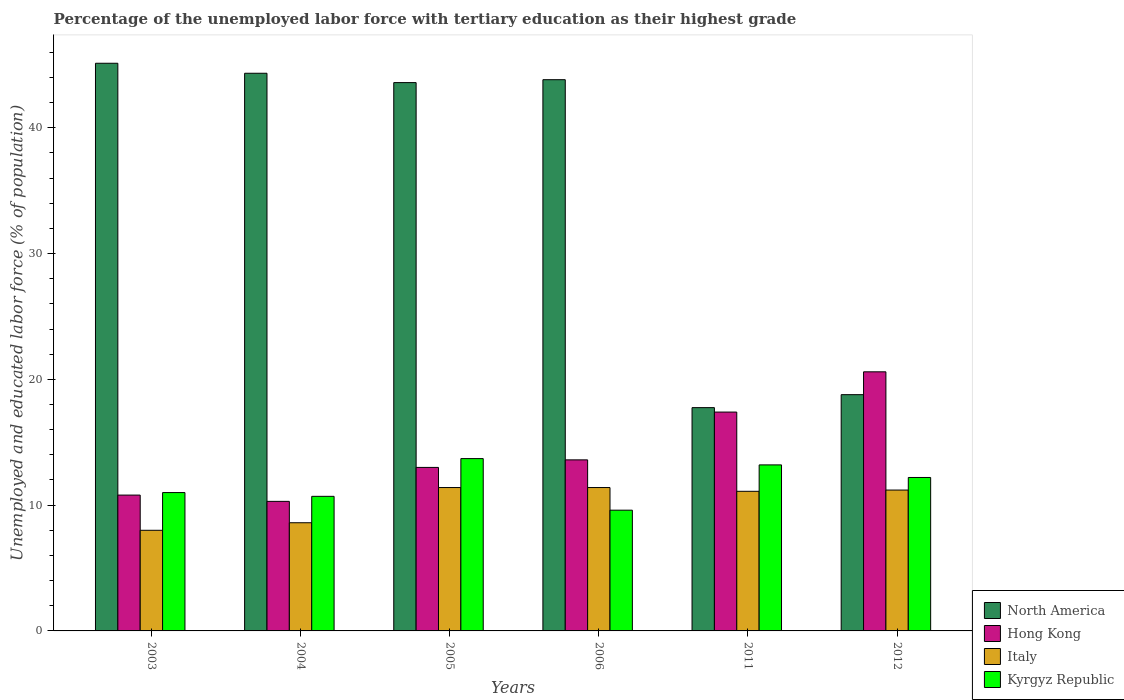How many different coloured bars are there?
Make the answer very short. 4. How many groups of bars are there?
Your answer should be compact. 6. Are the number of bars per tick equal to the number of legend labels?
Provide a short and direct response. Yes. Are the number of bars on each tick of the X-axis equal?
Provide a succinct answer. Yes. How many bars are there on the 5th tick from the right?
Give a very brief answer. 4. What is the percentage of the unemployed labor force with tertiary education in Italy in 2005?
Your answer should be compact. 11.4. Across all years, what is the maximum percentage of the unemployed labor force with tertiary education in North America?
Make the answer very short. 45.13. Across all years, what is the minimum percentage of the unemployed labor force with tertiary education in North America?
Keep it short and to the point. 17.75. What is the total percentage of the unemployed labor force with tertiary education in Kyrgyz Republic in the graph?
Your answer should be very brief. 70.4. What is the difference between the percentage of the unemployed labor force with tertiary education in Kyrgyz Republic in 2005 and that in 2011?
Provide a succinct answer. 0.5. What is the difference between the percentage of the unemployed labor force with tertiary education in North America in 2005 and the percentage of the unemployed labor force with tertiary education in Hong Kong in 2006?
Your response must be concise. 29.99. What is the average percentage of the unemployed labor force with tertiary education in North America per year?
Give a very brief answer. 35.57. In the year 2011, what is the difference between the percentage of the unemployed labor force with tertiary education in North America and percentage of the unemployed labor force with tertiary education in Kyrgyz Republic?
Offer a very short reply. 4.55. In how many years, is the percentage of the unemployed labor force with tertiary education in Italy greater than 36 %?
Offer a terse response. 0. What is the ratio of the percentage of the unemployed labor force with tertiary education in Italy in 2004 to that in 2012?
Offer a terse response. 0.77. What is the difference between the highest and the second highest percentage of the unemployed labor force with tertiary education in Hong Kong?
Provide a short and direct response. 3.2. What is the difference between the highest and the lowest percentage of the unemployed labor force with tertiary education in Kyrgyz Republic?
Ensure brevity in your answer.  4.1. What does the 4th bar from the left in 2006 represents?
Your response must be concise. Kyrgyz Republic. What does the 4th bar from the right in 2012 represents?
Make the answer very short. North America. Is it the case that in every year, the sum of the percentage of the unemployed labor force with tertiary education in Hong Kong and percentage of the unemployed labor force with tertiary education in Italy is greater than the percentage of the unemployed labor force with tertiary education in Kyrgyz Republic?
Ensure brevity in your answer.  Yes. How many bars are there?
Your response must be concise. 24. How many years are there in the graph?
Offer a terse response. 6. What is the difference between two consecutive major ticks on the Y-axis?
Keep it short and to the point. 10. Are the values on the major ticks of Y-axis written in scientific E-notation?
Your answer should be very brief. No. Does the graph contain any zero values?
Provide a succinct answer. No. Does the graph contain grids?
Offer a very short reply. No. How many legend labels are there?
Give a very brief answer. 4. How are the legend labels stacked?
Make the answer very short. Vertical. What is the title of the graph?
Provide a succinct answer. Percentage of the unemployed labor force with tertiary education as their highest grade. What is the label or title of the X-axis?
Your answer should be compact. Years. What is the label or title of the Y-axis?
Offer a terse response. Unemployed and educated labor force (% of population). What is the Unemployed and educated labor force (% of population) of North America in 2003?
Keep it short and to the point. 45.13. What is the Unemployed and educated labor force (% of population) in Hong Kong in 2003?
Make the answer very short. 10.8. What is the Unemployed and educated labor force (% of population) of North America in 2004?
Provide a succinct answer. 44.34. What is the Unemployed and educated labor force (% of population) of Hong Kong in 2004?
Offer a very short reply. 10.3. What is the Unemployed and educated labor force (% of population) of Italy in 2004?
Your response must be concise. 8.6. What is the Unemployed and educated labor force (% of population) of Kyrgyz Republic in 2004?
Ensure brevity in your answer.  10.7. What is the Unemployed and educated labor force (% of population) in North America in 2005?
Your answer should be compact. 43.59. What is the Unemployed and educated labor force (% of population) in Hong Kong in 2005?
Give a very brief answer. 13. What is the Unemployed and educated labor force (% of population) of Italy in 2005?
Offer a terse response. 11.4. What is the Unemployed and educated labor force (% of population) of Kyrgyz Republic in 2005?
Your answer should be compact. 13.7. What is the Unemployed and educated labor force (% of population) in North America in 2006?
Give a very brief answer. 43.82. What is the Unemployed and educated labor force (% of population) of Hong Kong in 2006?
Keep it short and to the point. 13.6. What is the Unemployed and educated labor force (% of population) of Italy in 2006?
Make the answer very short. 11.4. What is the Unemployed and educated labor force (% of population) of Kyrgyz Republic in 2006?
Offer a very short reply. 9.6. What is the Unemployed and educated labor force (% of population) of North America in 2011?
Your answer should be compact. 17.75. What is the Unemployed and educated labor force (% of population) in Hong Kong in 2011?
Ensure brevity in your answer.  17.4. What is the Unemployed and educated labor force (% of population) in Italy in 2011?
Provide a succinct answer. 11.1. What is the Unemployed and educated labor force (% of population) in Kyrgyz Republic in 2011?
Give a very brief answer. 13.2. What is the Unemployed and educated labor force (% of population) of North America in 2012?
Keep it short and to the point. 18.78. What is the Unemployed and educated labor force (% of population) in Hong Kong in 2012?
Your response must be concise. 20.6. What is the Unemployed and educated labor force (% of population) of Italy in 2012?
Your answer should be compact. 11.2. What is the Unemployed and educated labor force (% of population) of Kyrgyz Republic in 2012?
Your answer should be compact. 12.2. Across all years, what is the maximum Unemployed and educated labor force (% of population) in North America?
Offer a very short reply. 45.13. Across all years, what is the maximum Unemployed and educated labor force (% of population) of Hong Kong?
Your response must be concise. 20.6. Across all years, what is the maximum Unemployed and educated labor force (% of population) in Italy?
Keep it short and to the point. 11.4. Across all years, what is the maximum Unemployed and educated labor force (% of population) in Kyrgyz Republic?
Keep it short and to the point. 13.7. Across all years, what is the minimum Unemployed and educated labor force (% of population) in North America?
Your response must be concise. 17.75. Across all years, what is the minimum Unemployed and educated labor force (% of population) of Hong Kong?
Ensure brevity in your answer.  10.3. Across all years, what is the minimum Unemployed and educated labor force (% of population) of Kyrgyz Republic?
Your response must be concise. 9.6. What is the total Unemployed and educated labor force (% of population) of North America in the graph?
Your response must be concise. 213.42. What is the total Unemployed and educated labor force (% of population) of Hong Kong in the graph?
Make the answer very short. 85.7. What is the total Unemployed and educated labor force (% of population) in Italy in the graph?
Offer a very short reply. 61.7. What is the total Unemployed and educated labor force (% of population) of Kyrgyz Republic in the graph?
Give a very brief answer. 70.4. What is the difference between the Unemployed and educated labor force (% of population) of North America in 2003 and that in 2004?
Ensure brevity in your answer.  0.8. What is the difference between the Unemployed and educated labor force (% of population) of North America in 2003 and that in 2005?
Your answer should be compact. 1.54. What is the difference between the Unemployed and educated labor force (% of population) in Italy in 2003 and that in 2005?
Provide a succinct answer. -3.4. What is the difference between the Unemployed and educated labor force (% of population) of North America in 2003 and that in 2006?
Offer a very short reply. 1.31. What is the difference between the Unemployed and educated labor force (% of population) of Hong Kong in 2003 and that in 2006?
Keep it short and to the point. -2.8. What is the difference between the Unemployed and educated labor force (% of population) of North America in 2003 and that in 2011?
Offer a terse response. 27.38. What is the difference between the Unemployed and educated labor force (% of population) of Italy in 2003 and that in 2011?
Provide a short and direct response. -3.1. What is the difference between the Unemployed and educated labor force (% of population) of Kyrgyz Republic in 2003 and that in 2011?
Offer a terse response. -2.2. What is the difference between the Unemployed and educated labor force (% of population) of North America in 2003 and that in 2012?
Your answer should be very brief. 26.35. What is the difference between the Unemployed and educated labor force (% of population) of North America in 2004 and that in 2005?
Ensure brevity in your answer.  0.74. What is the difference between the Unemployed and educated labor force (% of population) of Italy in 2004 and that in 2005?
Provide a short and direct response. -2.8. What is the difference between the Unemployed and educated labor force (% of population) of North America in 2004 and that in 2006?
Provide a short and direct response. 0.51. What is the difference between the Unemployed and educated labor force (% of population) in Hong Kong in 2004 and that in 2006?
Your response must be concise. -3.3. What is the difference between the Unemployed and educated labor force (% of population) of North America in 2004 and that in 2011?
Provide a succinct answer. 26.58. What is the difference between the Unemployed and educated labor force (% of population) of Hong Kong in 2004 and that in 2011?
Your answer should be compact. -7.1. What is the difference between the Unemployed and educated labor force (% of population) of Kyrgyz Republic in 2004 and that in 2011?
Provide a short and direct response. -2.5. What is the difference between the Unemployed and educated labor force (% of population) of North America in 2004 and that in 2012?
Ensure brevity in your answer.  25.55. What is the difference between the Unemployed and educated labor force (% of population) in Hong Kong in 2004 and that in 2012?
Keep it short and to the point. -10.3. What is the difference between the Unemployed and educated labor force (% of population) of North America in 2005 and that in 2006?
Provide a short and direct response. -0.23. What is the difference between the Unemployed and educated labor force (% of population) in Hong Kong in 2005 and that in 2006?
Offer a terse response. -0.6. What is the difference between the Unemployed and educated labor force (% of population) in Kyrgyz Republic in 2005 and that in 2006?
Give a very brief answer. 4.1. What is the difference between the Unemployed and educated labor force (% of population) of North America in 2005 and that in 2011?
Your answer should be very brief. 25.84. What is the difference between the Unemployed and educated labor force (% of population) in Hong Kong in 2005 and that in 2011?
Ensure brevity in your answer.  -4.4. What is the difference between the Unemployed and educated labor force (% of population) of Italy in 2005 and that in 2011?
Keep it short and to the point. 0.3. What is the difference between the Unemployed and educated labor force (% of population) of Kyrgyz Republic in 2005 and that in 2011?
Offer a very short reply. 0.5. What is the difference between the Unemployed and educated labor force (% of population) in North America in 2005 and that in 2012?
Your response must be concise. 24.81. What is the difference between the Unemployed and educated labor force (% of population) of Italy in 2005 and that in 2012?
Keep it short and to the point. 0.2. What is the difference between the Unemployed and educated labor force (% of population) of Kyrgyz Republic in 2005 and that in 2012?
Your response must be concise. 1.5. What is the difference between the Unemployed and educated labor force (% of population) of North America in 2006 and that in 2011?
Offer a very short reply. 26.07. What is the difference between the Unemployed and educated labor force (% of population) of Hong Kong in 2006 and that in 2011?
Provide a succinct answer. -3.8. What is the difference between the Unemployed and educated labor force (% of population) of Italy in 2006 and that in 2011?
Ensure brevity in your answer.  0.3. What is the difference between the Unemployed and educated labor force (% of population) of North America in 2006 and that in 2012?
Ensure brevity in your answer.  25.04. What is the difference between the Unemployed and educated labor force (% of population) of Hong Kong in 2006 and that in 2012?
Your answer should be very brief. -7. What is the difference between the Unemployed and educated labor force (% of population) of North America in 2011 and that in 2012?
Keep it short and to the point. -1.03. What is the difference between the Unemployed and educated labor force (% of population) in Hong Kong in 2011 and that in 2012?
Provide a short and direct response. -3.2. What is the difference between the Unemployed and educated labor force (% of population) in Kyrgyz Republic in 2011 and that in 2012?
Keep it short and to the point. 1. What is the difference between the Unemployed and educated labor force (% of population) of North America in 2003 and the Unemployed and educated labor force (% of population) of Hong Kong in 2004?
Offer a very short reply. 34.83. What is the difference between the Unemployed and educated labor force (% of population) in North America in 2003 and the Unemployed and educated labor force (% of population) in Italy in 2004?
Provide a short and direct response. 36.53. What is the difference between the Unemployed and educated labor force (% of population) in North America in 2003 and the Unemployed and educated labor force (% of population) in Kyrgyz Republic in 2004?
Keep it short and to the point. 34.43. What is the difference between the Unemployed and educated labor force (% of population) in Hong Kong in 2003 and the Unemployed and educated labor force (% of population) in Italy in 2004?
Your response must be concise. 2.2. What is the difference between the Unemployed and educated labor force (% of population) in Italy in 2003 and the Unemployed and educated labor force (% of population) in Kyrgyz Republic in 2004?
Offer a very short reply. -2.7. What is the difference between the Unemployed and educated labor force (% of population) of North America in 2003 and the Unemployed and educated labor force (% of population) of Hong Kong in 2005?
Your answer should be compact. 32.13. What is the difference between the Unemployed and educated labor force (% of population) in North America in 2003 and the Unemployed and educated labor force (% of population) in Italy in 2005?
Offer a very short reply. 33.73. What is the difference between the Unemployed and educated labor force (% of population) of North America in 2003 and the Unemployed and educated labor force (% of population) of Kyrgyz Republic in 2005?
Give a very brief answer. 31.43. What is the difference between the Unemployed and educated labor force (% of population) in Italy in 2003 and the Unemployed and educated labor force (% of population) in Kyrgyz Republic in 2005?
Offer a terse response. -5.7. What is the difference between the Unemployed and educated labor force (% of population) of North America in 2003 and the Unemployed and educated labor force (% of population) of Hong Kong in 2006?
Give a very brief answer. 31.53. What is the difference between the Unemployed and educated labor force (% of population) in North America in 2003 and the Unemployed and educated labor force (% of population) in Italy in 2006?
Offer a very short reply. 33.73. What is the difference between the Unemployed and educated labor force (% of population) of North America in 2003 and the Unemployed and educated labor force (% of population) of Kyrgyz Republic in 2006?
Your response must be concise. 35.53. What is the difference between the Unemployed and educated labor force (% of population) of Italy in 2003 and the Unemployed and educated labor force (% of population) of Kyrgyz Republic in 2006?
Your answer should be very brief. -1.6. What is the difference between the Unemployed and educated labor force (% of population) of North America in 2003 and the Unemployed and educated labor force (% of population) of Hong Kong in 2011?
Keep it short and to the point. 27.73. What is the difference between the Unemployed and educated labor force (% of population) in North America in 2003 and the Unemployed and educated labor force (% of population) in Italy in 2011?
Ensure brevity in your answer.  34.03. What is the difference between the Unemployed and educated labor force (% of population) of North America in 2003 and the Unemployed and educated labor force (% of population) of Kyrgyz Republic in 2011?
Offer a very short reply. 31.93. What is the difference between the Unemployed and educated labor force (% of population) in Hong Kong in 2003 and the Unemployed and educated labor force (% of population) in Kyrgyz Republic in 2011?
Ensure brevity in your answer.  -2.4. What is the difference between the Unemployed and educated labor force (% of population) of Italy in 2003 and the Unemployed and educated labor force (% of population) of Kyrgyz Republic in 2011?
Your answer should be very brief. -5.2. What is the difference between the Unemployed and educated labor force (% of population) in North America in 2003 and the Unemployed and educated labor force (% of population) in Hong Kong in 2012?
Provide a succinct answer. 24.53. What is the difference between the Unemployed and educated labor force (% of population) in North America in 2003 and the Unemployed and educated labor force (% of population) in Italy in 2012?
Ensure brevity in your answer.  33.93. What is the difference between the Unemployed and educated labor force (% of population) of North America in 2003 and the Unemployed and educated labor force (% of population) of Kyrgyz Republic in 2012?
Offer a terse response. 32.93. What is the difference between the Unemployed and educated labor force (% of population) of Hong Kong in 2003 and the Unemployed and educated labor force (% of population) of Italy in 2012?
Provide a succinct answer. -0.4. What is the difference between the Unemployed and educated labor force (% of population) in Italy in 2003 and the Unemployed and educated labor force (% of population) in Kyrgyz Republic in 2012?
Offer a very short reply. -4.2. What is the difference between the Unemployed and educated labor force (% of population) of North America in 2004 and the Unemployed and educated labor force (% of population) of Hong Kong in 2005?
Give a very brief answer. 31.34. What is the difference between the Unemployed and educated labor force (% of population) of North America in 2004 and the Unemployed and educated labor force (% of population) of Italy in 2005?
Ensure brevity in your answer.  32.94. What is the difference between the Unemployed and educated labor force (% of population) in North America in 2004 and the Unemployed and educated labor force (% of population) in Kyrgyz Republic in 2005?
Make the answer very short. 30.64. What is the difference between the Unemployed and educated labor force (% of population) of Hong Kong in 2004 and the Unemployed and educated labor force (% of population) of Italy in 2005?
Offer a terse response. -1.1. What is the difference between the Unemployed and educated labor force (% of population) in Italy in 2004 and the Unemployed and educated labor force (% of population) in Kyrgyz Republic in 2005?
Give a very brief answer. -5.1. What is the difference between the Unemployed and educated labor force (% of population) in North America in 2004 and the Unemployed and educated labor force (% of population) in Hong Kong in 2006?
Offer a terse response. 30.74. What is the difference between the Unemployed and educated labor force (% of population) of North America in 2004 and the Unemployed and educated labor force (% of population) of Italy in 2006?
Ensure brevity in your answer.  32.94. What is the difference between the Unemployed and educated labor force (% of population) in North America in 2004 and the Unemployed and educated labor force (% of population) in Kyrgyz Republic in 2006?
Keep it short and to the point. 34.74. What is the difference between the Unemployed and educated labor force (% of population) in North America in 2004 and the Unemployed and educated labor force (% of population) in Hong Kong in 2011?
Give a very brief answer. 26.94. What is the difference between the Unemployed and educated labor force (% of population) in North America in 2004 and the Unemployed and educated labor force (% of population) in Italy in 2011?
Keep it short and to the point. 33.24. What is the difference between the Unemployed and educated labor force (% of population) of North America in 2004 and the Unemployed and educated labor force (% of population) of Kyrgyz Republic in 2011?
Give a very brief answer. 31.14. What is the difference between the Unemployed and educated labor force (% of population) of Hong Kong in 2004 and the Unemployed and educated labor force (% of population) of Kyrgyz Republic in 2011?
Your response must be concise. -2.9. What is the difference between the Unemployed and educated labor force (% of population) of Italy in 2004 and the Unemployed and educated labor force (% of population) of Kyrgyz Republic in 2011?
Provide a succinct answer. -4.6. What is the difference between the Unemployed and educated labor force (% of population) of North America in 2004 and the Unemployed and educated labor force (% of population) of Hong Kong in 2012?
Give a very brief answer. 23.74. What is the difference between the Unemployed and educated labor force (% of population) in North America in 2004 and the Unemployed and educated labor force (% of population) in Italy in 2012?
Your answer should be very brief. 33.14. What is the difference between the Unemployed and educated labor force (% of population) in North America in 2004 and the Unemployed and educated labor force (% of population) in Kyrgyz Republic in 2012?
Ensure brevity in your answer.  32.14. What is the difference between the Unemployed and educated labor force (% of population) in North America in 2005 and the Unemployed and educated labor force (% of population) in Hong Kong in 2006?
Offer a very short reply. 29.99. What is the difference between the Unemployed and educated labor force (% of population) in North America in 2005 and the Unemployed and educated labor force (% of population) in Italy in 2006?
Provide a short and direct response. 32.19. What is the difference between the Unemployed and educated labor force (% of population) in North America in 2005 and the Unemployed and educated labor force (% of population) in Kyrgyz Republic in 2006?
Offer a very short reply. 33.99. What is the difference between the Unemployed and educated labor force (% of population) of Hong Kong in 2005 and the Unemployed and educated labor force (% of population) of Kyrgyz Republic in 2006?
Offer a very short reply. 3.4. What is the difference between the Unemployed and educated labor force (% of population) of North America in 2005 and the Unemployed and educated labor force (% of population) of Hong Kong in 2011?
Your response must be concise. 26.19. What is the difference between the Unemployed and educated labor force (% of population) in North America in 2005 and the Unemployed and educated labor force (% of population) in Italy in 2011?
Your response must be concise. 32.49. What is the difference between the Unemployed and educated labor force (% of population) in North America in 2005 and the Unemployed and educated labor force (% of population) in Kyrgyz Republic in 2011?
Ensure brevity in your answer.  30.39. What is the difference between the Unemployed and educated labor force (% of population) of Hong Kong in 2005 and the Unemployed and educated labor force (% of population) of Italy in 2011?
Offer a very short reply. 1.9. What is the difference between the Unemployed and educated labor force (% of population) in North America in 2005 and the Unemployed and educated labor force (% of population) in Hong Kong in 2012?
Your answer should be compact. 22.99. What is the difference between the Unemployed and educated labor force (% of population) in North America in 2005 and the Unemployed and educated labor force (% of population) in Italy in 2012?
Keep it short and to the point. 32.39. What is the difference between the Unemployed and educated labor force (% of population) of North America in 2005 and the Unemployed and educated labor force (% of population) of Kyrgyz Republic in 2012?
Ensure brevity in your answer.  31.39. What is the difference between the Unemployed and educated labor force (% of population) in Hong Kong in 2005 and the Unemployed and educated labor force (% of population) in Kyrgyz Republic in 2012?
Offer a very short reply. 0.8. What is the difference between the Unemployed and educated labor force (% of population) of Italy in 2005 and the Unemployed and educated labor force (% of population) of Kyrgyz Republic in 2012?
Offer a terse response. -0.8. What is the difference between the Unemployed and educated labor force (% of population) in North America in 2006 and the Unemployed and educated labor force (% of population) in Hong Kong in 2011?
Keep it short and to the point. 26.42. What is the difference between the Unemployed and educated labor force (% of population) of North America in 2006 and the Unemployed and educated labor force (% of population) of Italy in 2011?
Ensure brevity in your answer.  32.72. What is the difference between the Unemployed and educated labor force (% of population) in North America in 2006 and the Unemployed and educated labor force (% of population) in Kyrgyz Republic in 2011?
Give a very brief answer. 30.62. What is the difference between the Unemployed and educated labor force (% of population) in Hong Kong in 2006 and the Unemployed and educated labor force (% of population) in Italy in 2011?
Your answer should be very brief. 2.5. What is the difference between the Unemployed and educated labor force (% of population) in North America in 2006 and the Unemployed and educated labor force (% of population) in Hong Kong in 2012?
Offer a terse response. 23.22. What is the difference between the Unemployed and educated labor force (% of population) of North America in 2006 and the Unemployed and educated labor force (% of population) of Italy in 2012?
Ensure brevity in your answer.  32.62. What is the difference between the Unemployed and educated labor force (% of population) of North America in 2006 and the Unemployed and educated labor force (% of population) of Kyrgyz Republic in 2012?
Your answer should be compact. 31.62. What is the difference between the Unemployed and educated labor force (% of population) in Hong Kong in 2006 and the Unemployed and educated labor force (% of population) in Italy in 2012?
Your answer should be very brief. 2.4. What is the difference between the Unemployed and educated labor force (% of population) in North America in 2011 and the Unemployed and educated labor force (% of population) in Hong Kong in 2012?
Keep it short and to the point. -2.85. What is the difference between the Unemployed and educated labor force (% of population) of North America in 2011 and the Unemployed and educated labor force (% of population) of Italy in 2012?
Offer a very short reply. 6.55. What is the difference between the Unemployed and educated labor force (% of population) in North America in 2011 and the Unemployed and educated labor force (% of population) in Kyrgyz Republic in 2012?
Offer a very short reply. 5.55. What is the difference between the Unemployed and educated labor force (% of population) in Hong Kong in 2011 and the Unemployed and educated labor force (% of population) in Italy in 2012?
Ensure brevity in your answer.  6.2. What is the difference between the Unemployed and educated labor force (% of population) of Italy in 2011 and the Unemployed and educated labor force (% of population) of Kyrgyz Republic in 2012?
Give a very brief answer. -1.1. What is the average Unemployed and educated labor force (% of population) of North America per year?
Make the answer very short. 35.57. What is the average Unemployed and educated labor force (% of population) in Hong Kong per year?
Ensure brevity in your answer.  14.28. What is the average Unemployed and educated labor force (% of population) of Italy per year?
Offer a terse response. 10.28. What is the average Unemployed and educated labor force (% of population) in Kyrgyz Republic per year?
Give a very brief answer. 11.73. In the year 2003, what is the difference between the Unemployed and educated labor force (% of population) of North America and Unemployed and educated labor force (% of population) of Hong Kong?
Your answer should be very brief. 34.33. In the year 2003, what is the difference between the Unemployed and educated labor force (% of population) in North America and Unemployed and educated labor force (% of population) in Italy?
Provide a short and direct response. 37.13. In the year 2003, what is the difference between the Unemployed and educated labor force (% of population) in North America and Unemployed and educated labor force (% of population) in Kyrgyz Republic?
Your response must be concise. 34.13. In the year 2003, what is the difference between the Unemployed and educated labor force (% of population) in Hong Kong and Unemployed and educated labor force (% of population) in Kyrgyz Republic?
Offer a very short reply. -0.2. In the year 2004, what is the difference between the Unemployed and educated labor force (% of population) of North America and Unemployed and educated labor force (% of population) of Hong Kong?
Your response must be concise. 34.04. In the year 2004, what is the difference between the Unemployed and educated labor force (% of population) in North America and Unemployed and educated labor force (% of population) in Italy?
Your answer should be compact. 35.74. In the year 2004, what is the difference between the Unemployed and educated labor force (% of population) in North America and Unemployed and educated labor force (% of population) in Kyrgyz Republic?
Ensure brevity in your answer.  33.64. In the year 2004, what is the difference between the Unemployed and educated labor force (% of population) in Hong Kong and Unemployed and educated labor force (% of population) in Italy?
Offer a terse response. 1.7. In the year 2004, what is the difference between the Unemployed and educated labor force (% of population) of Hong Kong and Unemployed and educated labor force (% of population) of Kyrgyz Republic?
Your answer should be very brief. -0.4. In the year 2005, what is the difference between the Unemployed and educated labor force (% of population) of North America and Unemployed and educated labor force (% of population) of Hong Kong?
Offer a very short reply. 30.59. In the year 2005, what is the difference between the Unemployed and educated labor force (% of population) in North America and Unemployed and educated labor force (% of population) in Italy?
Your response must be concise. 32.19. In the year 2005, what is the difference between the Unemployed and educated labor force (% of population) in North America and Unemployed and educated labor force (% of population) in Kyrgyz Republic?
Offer a terse response. 29.89. In the year 2005, what is the difference between the Unemployed and educated labor force (% of population) of Hong Kong and Unemployed and educated labor force (% of population) of Italy?
Give a very brief answer. 1.6. In the year 2005, what is the difference between the Unemployed and educated labor force (% of population) of Hong Kong and Unemployed and educated labor force (% of population) of Kyrgyz Republic?
Your answer should be very brief. -0.7. In the year 2005, what is the difference between the Unemployed and educated labor force (% of population) of Italy and Unemployed and educated labor force (% of population) of Kyrgyz Republic?
Ensure brevity in your answer.  -2.3. In the year 2006, what is the difference between the Unemployed and educated labor force (% of population) of North America and Unemployed and educated labor force (% of population) of Hong Kong?
Your response must be concise. 30.22. In the year 2006, what is the difference between the Unemployed and educated labor force (% of population) of North America and Unemployed and educated labor force (% of population) of Italy?
Offer a terse response. 32.42. In the year 2006, what is the difference between the Unemployed and educated labor force (% of population) of North America and Unemployed and educated labor force (% of population) of Kyrgyz Republic?
Offer a terse response. 34.22. In the year 2006, what is the difference between the Unemployed and educated labor force (% of population) in Hong Kong and Unemployed and educated labor force (% of population) in Italy?
Provide a short and direct response. 2.2. In the year 2011, what is the difference between the Unemployed and educated labor force (% of population) in North America and Unemployed and educated labor force (% of population) in Hong Kong?
Ensure brevity in your answer.  0.35. In the year 2011, what is the difference between the Unemployed and educated labor force (% of population) of North America and Unemployed and educated labor force (% of population) of Italy?
Your answer should be very brief. 6.65. In the year 2011, what is the difference between the Unemployed and educated labor force (% of population) in North America and Unemployed and educated labor force (% of population) in Kyrgyz Republic?
Offer a terse response. 4.55. In the year 2011, what is the difference between the Unemployed and educated labor force (% of population) in Hong Kong and Unemployed and educated labor force (% of population) in Italy?
Your response must be concise. 6.3. In the year 2012, what is the difference between the Unemployed and educated labor force (% of population) of North America and Unemployed and educated labor force (% of population) of Hong Kong?
Ensure brevity in your answer.  -1.82. In the year 2012, what is the difference between the Unemployed and educated labor force (% of population) in North America and Unemployed and educated labor force (% of population) in Italy?
Your answer should be very brief. 7.58. In the year 2012, what is the difference between the Unemployed and educated labor force (% of population) in North America and Unemployed and educated labor force (% of population) in Kyrgyz Republic?
Your response must be concise. 6.58. In the year 2012, what is the difference between the Unemployed and educated labor force (% of population) in Hong Kong and Unemployed and educated labor force (% of population) in Italy?
Offer a very short reply. 9.4. In the year 2012, what is the difference between the Unemployed and educated labor force (% of population) in Italy and Unemployed and educated labor force (% of population) in Kyrgyz Republic?
Provide a short and direct response. -1. What is the ratio of the Unemployed and educated labor force (% of population) in North America in 2003 to that in 2004?
Keep it short and to the point. 1.02. What is the ratio of the Unemployed and educated labor force (% of population) of Hong Kong in 2003 to that in 2004?
Provide a short and direct response. 1.05. What is the ratio of the Unemployed and educated labor force (% of population) in Italy in 2003 to that in 2004?
Ensure brevity in your answer.  0.93. What is the ratio of the Unemployed and educated labor force (% of population) of Kyrgyz Republic in 2003 to that in 2004?
Give a very brief answer. 1.03. What is the ratio of the Unemployed and educated labor force (% of population) in North America in 2003 to that in 2005?
Offer a very short reply. 1.04. What is the ratio of the Unemployed and educated labor force (% of population) of Hong Kong in 2003 to that in 2005?
Your answer should be compact. 0.83. What is the ratio of the Unemployed and educated labor force (% of population) in Italy in 2003 to that in 2005?
Provide a short and direct response. 0.7. What is the ratio of the Unemployed and educated labor force (% of population) of Kyrgyz Republic in 2003 to that in 2005?
Your answer should be compact. 0.8. What is the ratio of the Unemployed and educated labor force (% of population) in North America in 2003 to that in 2006?
Your answer should be compact. 1.03. What is the ratio of the Unemployed and educated labor force (% of population) in Hong Kong in 2003 to that in 2006?
Keep it short and to the point. 0.79. What is the ratio of the Unemployed and educated labor force (% of population) in Italy in 2003 to that in 2006?
Make the answer very short. 0.7. What is the ratio of the Unemployed and educated labor force (% of population) of Kyrgyz Republic in 2003 to that in 2006?
Your response must be concise. 1.15. What is the ratio of the Unemployed and educated labor force (% of population) in North America in 2003 to that in 2011?
Provide a succinct answer. 2.54. What is the ratio of the Unemployed and educated labor force (% of population) in Hong Kong in 2003 to that in 2011?
Make the answer very short. 0.62. What is the ratio of the Unemployed and educated labor force (% of population) of Italy in 2003 to that in 2011?
Your answer should be compact. 0.72. What is the ratio of the Unemployed and educated labor force (% of population) of Kyrgyz Republic in 2003 to that in 2011?
Provide a succinct answer. 0.83. What is the ratio of the Unemployed and educated labor force (% of population) of North America in 2003 to that in 2012?
Offer a terse response. 2.4. What is the ratio of the Unemployed and educated labor force (% of population) of Hong Kong in 2003 to that in 2012?
Offer a terse response. 0.52. What is the ratio of the Unemployed and educated labor force (% of population) in Italy in 2003 to that in 2012?
Offer a terse response. 0.71. What is the ratio of the Unemployed and educated labor force (% of population) in Kyrgyz Republic in 2003 to that in 2012?
Your response must be concise. 0.9. What is the ratio of the Unemployed and educated labor force (% of population) of Hong Kong in 2004 to that in 2005?
Your answer should be very brief. 0.79. What is the ratio of the Unemployed and educated labor force (% of population) in Italy in 2004 to that in 2005?
Your answer should be very brief. 0.75. What is the ratio of the Unemployed and educated labor force (% of population) in Kyrgyz Republic in 2004 to that in 2005?
Keep it short and to the point. 0.78. What is the ratio of the Unemployed and educated labor force (% of population) in North America in 2004 to that in 2006?
Provide a short and direct response. 1.01. What is the ratio of the Unemployed and educated labor force (% of population) of Hong Kong in 2004 to that in 2006?
Provide a succinct answer. 0.76. What is the ratio of the Unemployed and educated labor force (% of population) in Italy in 2004 to that in 2006?
Make the answer very short. 0.75. What is the ratio of the Unemployed and educated labor force (% of population) in Kyrgyz Republic in 2004 to that in 2006?
Your answer should be compact. 1.11. What is the ratio of the Unemployed and educated labor force (% of population) of North America in 2004 to that in 2011?
Your answer should be compact. 2.5. What is the ratio of the Unemployed and educated labor force (% of population) of Hong Kong in 2004 to that in 2011?
Provide a short and direct response. 0.59. What is the ratio of the Unemployed and educated labor force (% of population) in Italy in 2004 to that in 2011?
Your answer should be very brief. 0.77. What is the ratio of the Unemployed and educated labor force (% of population) in Kyrgyz Republic in 2004 to that in 2011?
Make the answer very short. 0.81. What is the ratio of the Unemployed and educated labor force (% of population) of North America in 2004 to that in 2012?
Give a very brief answer. 2.36. What is the ratio of the Unemployed and educated labor force (% of population) of Hong Kong in 2004 to that in 2012?
Make the answer very short. 0.5. What is the ratio of the Unemployed and educated labor force (% of population) of Italy in 2004 to that in 2012?
Ensure brevity in your answer.  0.77. What is the ratio of the Unemployed and educated labor force (% of population) in Kyrgyz Republic in 2004 to that in 2012?
Provide a succinct answer. 0.88. What is the ratio of the Unemployed and educated labor force (% of population) in Hong Kong in 2005 to that in 2006?
Offer a terse response. 0.96. What is the ratio of the Unemployed and educated labor force (% of population) in Kyrgyz Republic in 2005 to that in 2006?
Make the answer very short. 1.43. What is the ratio of the Unemployed and educated labor force (% of population) of North America in 2005 to that in 2011?
Ensure brevity in your answer.  2.46. What is the ratio of the Unemployed and educated labor force (% of population) of Hong Kong in 2005 to that in 2011?
Your answer should be compact. 0.75. What is the ratio of the Unemployed and educated labor force (% of population) in Italy in 2005 to that in 2011?
Your response must be concise. 1.03. What is the ratio of the Unemployed and educated labor force (% of population) in Kyrgyz Republic in 2005 to that in 2011?
Give a very brief answer. 1.04. What is the ratio of the Unemployed and educated labor force (% of population) in North America in 2005 to that in 2012?
Your answer should be compact. 2.32. What is the ratio of the Unemployed and educated labor force (% of population) in Hong Kong in 2005 to that in 2012?
Keep it short and to the point. 0.63. What is the ratio of the Unemployed and educated labor force (% of population) in Italy in 2005 to that in 2012?
Offer a terse response. 1.02. What is the ratio of the Unemployed and educated labor force (% of population) of Kyrgyz Republic in 2005 to that in 2012?
Your answer should be compact. 1.12. What is the ratio of the Unemployed and educated labor force (% of population) of North America in 2006 to that in 2011?
Provide a succinct answer. 2.47. What is the ratio of the Unemployed and educated labor force (% of population) in Hong Kong in 2006 to that in 2011?
Offer a terse response. 0.78. What is the ratio of the Unemployed and educated labor force (% of population) in Italy in 2006 to that in 2011?
Ensure brevity in your answer.  1.03. What is the ratio of the Unemployed and educated labor force (% of population) of Kyrgyz Republic in 2006 to that in 2011?
Offer a very short reply. 0.73. What is the ratio of the Unemployed and educated labor force (% of population) of North America in 2006 to that in 2012?
Your answer should be compact. 2.33. What is the ratio of the Unemployed and educated labor force (% of population) of Hong Kong in 2006 to that in 2012?
Ensure brevity in your answer.  0.66. What is the ratio of the Unemployed and educated labor force (% of population) of Italy in 2006 to that in 2012?
Provide a short and direct response. 1.02. What is the ratio of the Unemployed and educated labor force (% of population) of Kyrgyz Republic in 2006 to that in 2012?
Offer a very short reply. 0.79. What is the ratio of the Unemployed and educated labor force (% of population) in North America in 2011 to that in 2012?
Keep it short and to the point. 0.95. What is the ratio of the Unemployed and educated labor force (% of population) in Hong Kong in 2011 to that in 2012?
Make the answer very short. 0.84. What is the ratio of the Unemployed and educated labor force (% of population) in Kyrgyz Republic in 2011 to that in 2012?
Keep it short and to the point. 1.08. What is the difference between the highest and the second highest Unemployed and educated labor force (% of population) in North America?
Provide a succinct answer. 0.8. What is the difference between the highest and the lowest Unemployed and educated labor force (% of population) of North America?
Offer a very short reply. 27.38. What is the difference between the highest and the lowest Unemployed and educated labor force (% of population) of Hong Kong?
Your answer should be compact. 10.3. What is the difference between the highest and the lowest Unemployed and educated labor force (% of population) of Italy?
Make the answer very short. 3.4. 